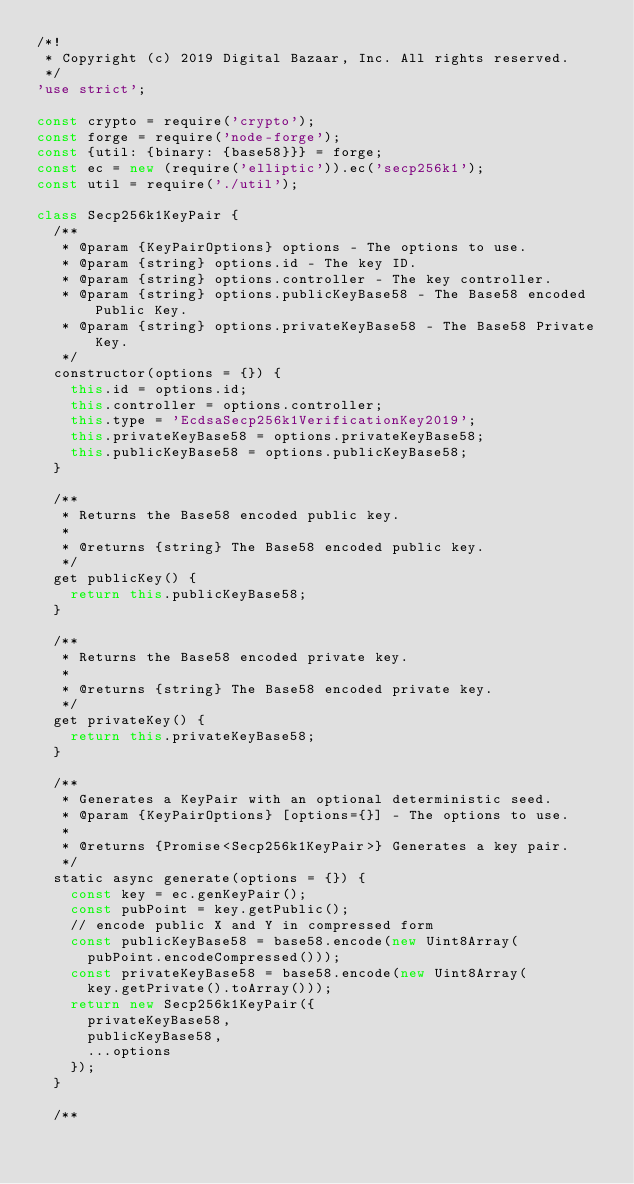Convert code to text. <code><loc_0><loc_0><loc_500><loc_500><_JavaScript_>/*!
 * Copyright (c) 2019 Digital Bazaar, Inc. All rights reserved.
 */
'use strict';

const crypto = require('crypto');
const forge = require('node-forge');
const {util: {binary: {base58}}} = forge;
const ec = new (require('elliptic')).ec('secp256k1');
const util = require('./util');

class Secp256k1KeyPair {
  /**
   * @param {KeyPairOptions} options - The options to use.
   * @param {string} options.id - The key ID.
   * @param {string} options.controller - The key controller.
   * @param {string} options.publicKeyBase58 - The Base58 encoded Public Key.
   * @param {string} options.privateKeyBase58 - The Base58 Private Key.
   */
  constructor(options = {}) {
    this.id = options.id;
    this.controller = options.controller;
    this.type = 'EcdsaSecp256k1VerificationKey2019';
    this.privateKeyBase58 = options.privateKeyBase58;
    this.publicKeyBase58 = options.publicKeyBase58;
  }

  /**
   * Returns the Base58 encoded public key.
   *
   * @returns {string} The Base58 encoded public key.
   */
  get publicKey() {
    return this.publicKeyBase58;
  }

  /**
   * Returns the Base58 encoded private key.
   *
   * @returns {string} The Base58 encoded private key.
   */
  get privateKey() {
    return this.privateKeyBase58;
  }

  /**
   * Generates a KeyPair with an optional deterministic seed.
   * @param {KeyPairOptions} [options={}] - The options to use.
   *
   * @returns {Promise<Secp256k1KeyPair>} Generates a key pair.
   */
  static async generate(options = {}) {
    const key = ec.genKeyPair();
    const pubPoint = key.getPublic();
    // encode public X and Y in compressed form
    const publicKeyBase58 = base58.encode(new Uint8Array(
      pubPoint.encodeCompressed()));
    const privateKeyBase58 = base58.encode(new Uint8Array(
      key.getPrivate().toArray()));
    return new Secp256k1KeyPair({
      privateKeyBase58,
      publicKeyBase58,
      ...options
    });
  }

  /**</code> 